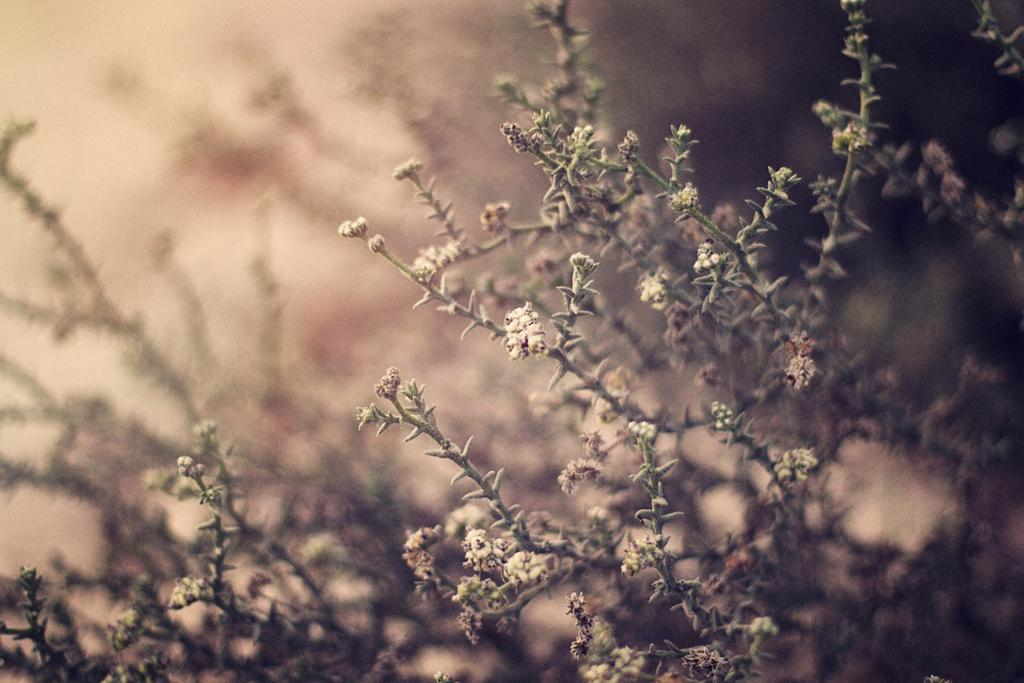What type of living organisms can be seen in the image? There are flowers in the image. What can be seen in the background of the image? There are plants in the background of the image. How does the crowd interact with the flowers in the image? There is no crowd present in the image; it only features flowers and plants. What type of care is being provided to the flowers in the image? The image does not show any care being provided to the flowers, nor does it show any people interacting with them. 